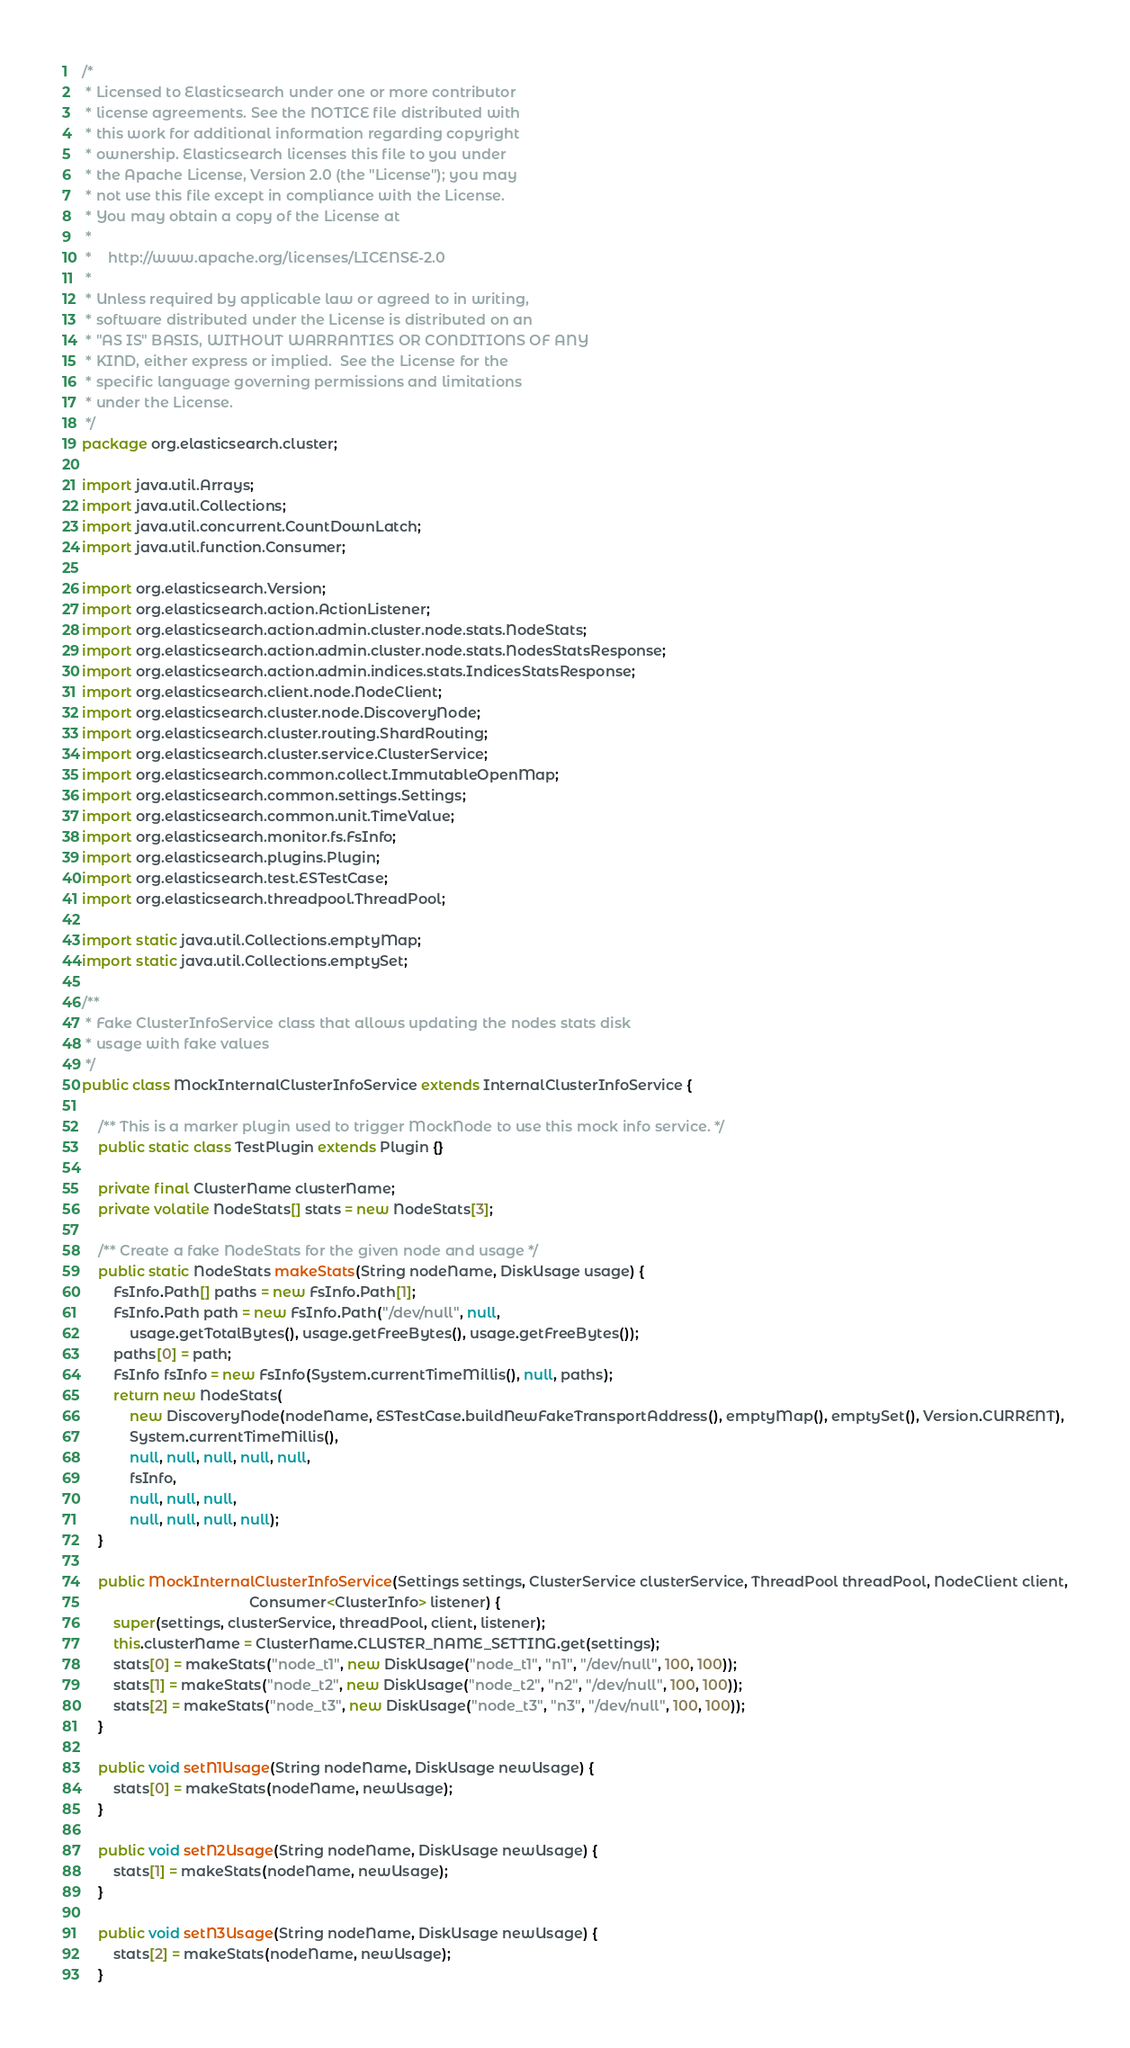<code> <loc_0><loc_0><loc_500><loc_500><_Java_>/*
 * Licensed to Elasticsearch under one or more contributor
 * license agreements. See the NOTICE file distributed with
 * this work for additional information regarding copyright
 * ownership. Elasticsearch licenses this file to you under
 * the Apache License, Version 2.0 (the "License"); you may
 * not use this file except in compliance with the License.
 * You may obtain a copy of the License at
 *
 *    http://www.apache.org/licenses/LICENSE-2.0
 *
 * Unless required by applicable law or agreed to in writing,
 * software distributed under the License is distributed on an
 * "AS IS" BASIS, WITHOUT WARRANTIES OR CONDITIONS OF ANY
 * KIND, either express or implied.  See the License for the
 * specific language governing permissions and limitations
 * under the License.
 */
package org.elasticsearch.cluster;

import java.util.Arrays;
import java.util.Collections;
import java.util.concurrent.CountDownLatch;
import java.util.function.Consumer;

import org.elasticsearch.Version;
import org.elasticsearch.action.ActionListener;
import org.elasticsearch.action.admin.cluster.node.stats.NodeStats;
import org.elasticsearch.action.admin.cluster.node.stats.NodesStatsResponse;
import org.elasticsearch.action.admin.indices.stats.IndicesStatsResponse;
import org.elasticsearch.client.node.NodeClient;
import org.elasticsearch.cluster.node.DiscoveryNode;
import org.elasticsearch.cluster.routing.ShardRouting;
import org.elasticsearch.cluster.service.ClusterService;
import org.elasticsearch.common.collect.ImmutableOpenMap;
import org.elasticsearch.common.settings.Settings;
import org.elasticsearch.common.unit.TimeValue;
import org.elasticsearch.monitor.fs.FsInfo;
import org.elasticsearch.plugins.Plugin;
import org.elasticsearch.test.ESTestCase;
import org.elasticsearch.threadpool.ThreadPool;

import static java.util.Collections.emptyMap;
import static java.util.Collections.emptySet;

/**
 * Fake ClusterInfoService class that allows updating the nodes stats disk
 * usage with fake values
 */
public class MockInternalClusterInfoService extends InternalClusterInfoService {

    /** This is a marker plugin used to trigger MockNode to use this mock info service. */
    public static class TestPlugin extends Plugin {}

    private final ClusterName clusterName;
    private volatile NodeStats[] stats = new NodeStats[3];

    /** Create a fake NodeStats for the given node and usage */
    public static NodeStats makeStats(String nodeName, DiskUsage usage) {
        FsInfo.Path[] paths = new FsInfo.Path[1];
        FsInfo.Path path = new FsInfo.Path("/dev/null", null,
            usage.getTotalBytes(), usage.getFreeBytes(), usage.getFreeBytes());
        paths[0] = path;
        FsInfo fsInfo = new FsInfo(System.currentTimeMillis(), null, paths);
        return new NodeStats(
            new DiscoveryNode(nodeName, ESTestCase.buildNewFakeTransportAddress(), emptyMap(), emptySet(), Version.CURRENT),
            System.currentTimeMillis(),
            null, null, null, null, null,
            fsInfo,
            null, null, null,
            null, null, null, null);
    }

    public MockInternalClusterInfoService(Settings settings, ClusterService clusterService, ThreadPool threadPool, NodeClient client,
                                          Consumer<ClusterInfo> listener) {
        super(settings, clusterService, threadPool, client, listener);
        this.clusterName = ClusterName.CLUSTER_NAME_SETTING.get(settings);
        stats[0] = makeStats("node_t1", new DiskUsage("node_t1", "n1", "/dev/null", 100, 100));
        stats[1] = makeStats("node_t2", new DiskUsage("node_t2", "n2", "/dev/null", 100, 100));
        stats[2] = makeStats("node_t3", new DiskUsage("node_t3", "n3", "/dev/null", 100, 100));
    }

    public void setN1Usage(String nodeName, DiskUsage newUsage) {
        stats[0] = makeStats(nodeName, newUsage);
    }

    public void setN2Usage(String nodeName, DiskUsage newUsage) {
        stats[1] = makeStats(nodeName, newUsage);
    }

    public void setN3Usage(String nodeName, DiskUsage newUsage) {
        stats[2] = makeStats(nodeName, newUsage);
    }
</code> 